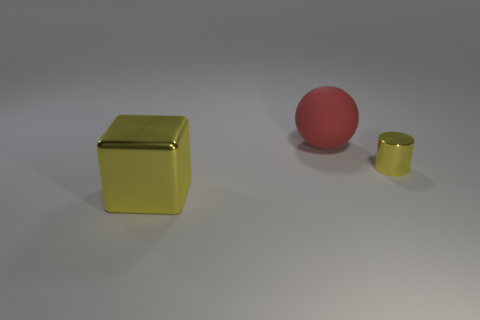There is a thing that is behind the yellow object on the right side of the large matte object; what color is it?
Your answer should be very brief. Red. What shape is the large yellow metal thing?
Make the answer very short. Cube. There is a yellow thing that is on the left side of the red rubber thing; is its size the same as the rubber ball?
Give a very brief answer. Yes. Are there any tiny cylinders made of the same material as the big yellow block?
Your answer should be very brief. Yes. How many things are shiny things that are on the left side of the matte object or big purple cylinders?
Offer a very short reply. 1. Are any green rubber cylinders visible?
Your answer should be compact. No. What is the shape of the object that is both in front of the large ball and left of the metal cylinder?
Offer a terse response. Cube. There is a yellow object that is on the right side of the yellow block; what is its size?
Ensure brevity in your answer.  Small. Do the metal object on the left side of the big rubber object and the cylinder have the same color?
Ensure brevity in your answer.  Yes. What number of things are large things behind the large yellow metal object or things that are behind the shiny cylinder?
Your answer should be very brief. 1. 